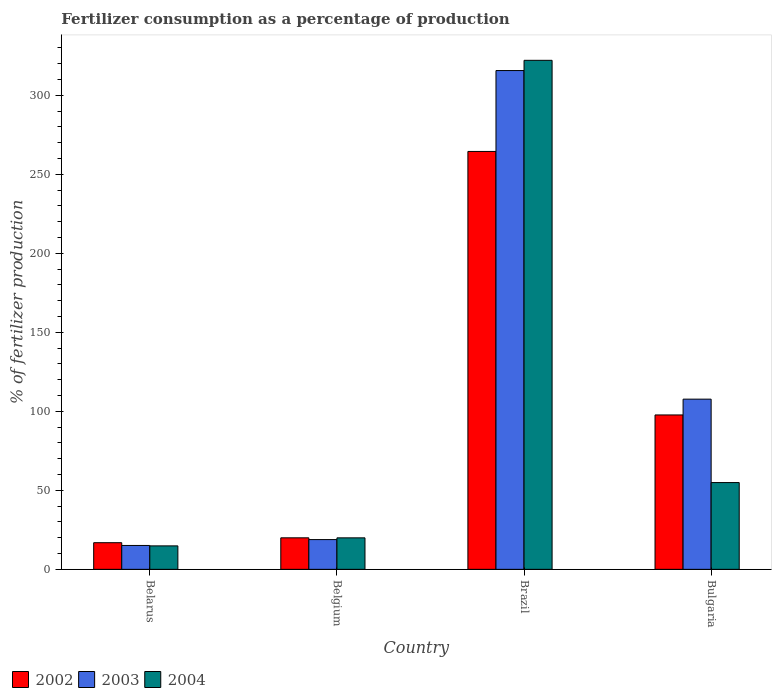How many different coloured bars are there?
Keep it short and to the point. 3. Are the number of bars per tick equal to the number of legend labels?
Give a very brief answer. Yes. Are the number of bars on each tick of the X-axis equal?
Provide a short and direct response. Yes. How many bars are there on the 1st tick from the left?
Your answer should be compact. 3. What is the percentage of fertilizers consumed in 2004 in Belgium?
Provide a succinct answer. 19.93. Across all countries, what is the maximum percentage of fertilizers consumed in 2002?
Give a very brief answer. 264.49. Across all countries, what is the minimum percentage of fertilizers consumed in 2003?
Your answer should be compact. 15.11. In which country was the percentage of fertilizers consumed in 2002 minimum?
Your response must be concise. Belarus. What is the total percentage of fertilizers consumed in 2004 in the graph?
Your response must be concise. 411.84. What is the difference between the percentage of fertilizers consumed in 2003 in Brazil and that in Bulgaria?
Keep it short and to the point. 207.97. What is the difference between the percentage of fertilizers consumed in 2002 in Belgium and the percentage of fertilizers consumed in 2003 in Belarus?
Provide a succinct answer. 4.83. What is the average percentage of fertilizers consumed in 2002 per country?
Make the answer very short. 99.75. What is the difference between the percentage of fertilizers consumed of/in 2004 and percentage of fertilizers consumed of/in 2002 in Belgium?
Your answer should be compact. -0.01. In how many countries, is the percentage of fertilizers consumed in 2002 greater than 310 %?
Offer a very short reply. 0. What is the ratio of the percentage of fertilizers consumed in 2003 in Belarus to that in Bulgaria?
Your response must be concise. 0.14. Is the difference between the percentage of fertilizers consumed in 2004 in Brazil and Bulgaria greater than the difference between the percentage of fertilizers consumed in 2002 in Brazil and Bulgaria?
Your response must be concise. Yes. What is the difference between the highest and the second highest percentage of fertilizers consumed in 2003?
Your answer should be very brief. 88.89. What is the difference between the highest and the lowest percentage of fertilizers consumed in 2004?
Make the answer very short. 307.32. In how many countries, is the percentage of fertilizers consumed in 2003 greater than the average percentage of fertilizers consumed in 2003 taken over all countries?
Give a very brief answer. 1. Is the sum of the percentage of fertilizers consumed in 2002 in Belgium and Bulgaria greater than the maximum percentage of fertilizers consumed in 2004 across all countries?
Your response must be concise. No. Is it the case that in every country, the sum of the percentage of fertilizers consumed in 2004 and percentage of fertilizers consumed in 2003 is greater than the percentage of fertilizers consumed in 2002?
Your answer should be compact. Yes. How many bars are there?
Offer a terse response. 12. Are all the bars in the graph horizontal?
Offer a very short reply. No. How many countries are there in the graph?
Provide a succinct answer. 4. What is the title of the graph?
Ensure brevity in your answer.  Fertilizer consumption as a percentage of production. Does "1988" appear as one of the legend labels in the graph?
Your answer should be compact. No. What is the label or title of the X-axis?
Your answer should be compact. Country. What is the label or title of the Y-axis?
Your answer should be very brief. % of fertilizer production. What is the % of fertilizer production of 2002 in Belarus?
Your answer should be compact. 16.86. What is the % of fertilizer production in 2003 in Belarus?
Offer a terse response. 15.11. What is the % of fertilizer production of 2004 in Belarus?
Your response must be concise. 14.84. What is the % of fertilizer production in 2002 in Belgium?
Your answer should be very brief. 19.94. What is the % of fertilizer production in 2003 in Belgium?
Your answer should be very brief. 18.83. What is the % of fertilizer production in 2004 in Belgium?
Offer a very short reply. 19.93. What is the % of fertilizer production in 2002 in Brazil?
Make the answer very short. 264.49. What is the % of fertilizer production in 2003 in Brazil?
Provide a succinct answer. 315.68. What is the % of fertilizer production of 2004 in Brazil?
Offer a very short reply. 322.16. What is the % of fertilizer production in 2002 in Bulgaria?
Your response must be concise. 97.71. What is the % of fertilizer production of 2003 in Bulgaria?
Provide a succinct answer. 107.72. What is the % of fertilizer production in 2004 in Bulgaria?
Provide a succinct answer. 54.91. Across all countries, what is the maximum % of fertilizer production in 2002?
Keep it short and to the point. 264.49. Across all countries, what is the maximum % of fertilizer production of 2003?
Give a very brief answer. 315.68. Across all countries, what is the maximum % of fertilizer production of 2004?
Keep it short and to the point. 322.16. Across all countries, what is the minimum % of fertilizer production in 2002?
Your answer should be very brief. 16.86. Across all countries, what is the minimum % of fertilizer production in 2003?
Your answer should be compact. 15.11. Across all countries, what is the minimum % of fertilizer production in 2004?
Your response must be concise. 14.84. What is the total % of fertilizer production of 2002 in the graph?
Your response must be concise. 399. What is the total % of fertilizer production in 2003 in the graph?
Offer a terse response. 457.34. What is the total % of fertilizer production in 2004 in the graph?
Your response must be concise. 411.84. What is the difference between the % of fertilizer production in 2002 in Belarus and that in Belgium?
Provide a succinct answer. -3.08. What is the difference between the % of fertilizer production in 2003 in Belarus and that in Belgium?
Give a very brief answer. -3.72. What is the difference between the % of fertilizer production of 2004 in Belarus and that in Belgium?
Offer a very short reply. -5.09. What is the difference between the % of fertilizer production in 2002 in Belarus and that in Brazil?
Offer a very short reply. -247.63. What is the difference between the % of fertilizer production of 2003 in Belarus and that in Brazil?
Provide a succinct answer. -300.57. What is the difference between the % of fertilizer production of 2004 in Belarus and that in Brazil?
Your response must be concise. -307.31. What is the difference between the % of fertilizer production in 2002 in Belarus and that in Bulgaria?
Ensure brevity in your answer.  -80.85. What is the difference between the % of fertilizer production in 2003 in Belarus and that in Bulgaria?
Your response must be concise. -92.61. What is the difference between the % of fertilizer production in 2004 in Belarus and that in Bulgaria?
Your response must be concise. -40.07. What is the difference between the % of fertilizer production of 2002 in Belgium and that in Brazil?
Your answer should be very brief. -244.55. What is the difference between the % of fertilizer production in 2003 in Belgium and that in Brazil?
Your response must be concise. -296.85. What is the difference between the % of fertilizer production in 2004 in Belgium and that in Brazil?
Your answer should be compact. -302.23. What is the difference between the % of fertilizer production in 2002 in Belgium and that in Bulgaria?
Give a very brief answer. -77.77. What is the difference between the % of fertilizer production of 2003 in Belgium and that in Bulgaria?
Keep it short and to the point. -88.89. What is the difference between the % of fertilizer production of 2004 in Belgium and that in Bulgaria?
Offer a very short reply. -34.98. What is the difference between the % of fertilizer production of 2002 in Brazil and that in Bulgaria?
Keep it short and to the point. 166.78. What is the difference between the % of fertilizer production in 2003 in Brazil and that in Bulgaria?
Offer a very short reply. 207.97. What is the difference between the % of fertilizer production in 2004 in Brazil and that in Bulgaria?
Offer a terse response. 267.25. What is the difference between the % of fertilizer production in 2002 in Belarus and the % of fertilizer production in 2003 in Belgium?
Your answer should be compact. -1.97. What is the difference between the % of fertilizer production in 2002 in Belarus and the % of fertilizer production in 2004 in Belgium?
Offer a very short reply. -3.07. What is the difference between the % of fertilizer production of 2003 in Belarus and the % of fertilizer production of 2004 in Belgium?
Your answer should be very brief. -4.82. What is the difference between the % of fertilizer production of 2002 in Belarus and the % of fertilizer production of 2003 in Brazil?
Provide a succinct answer. -298.83. What is the difference between the % of fertilizer production in 2002 in Belarus and the % of fertilizer production in 2004 in Brazil?
Your answer should be compact. -305.3. What is the difference between the % of fertilizer production of 2003 in Belarus and the % of fertilizer production of 2004 in Brazil?
Give a very brief answer. -307.05. What is the difference between the % of fertilizer production in 2002 in Belarus and the % of fertilizer production in 2003 in Bulgaria?
Offer a very short reply. -90.86. What is the difference between the % of fertilizer production of 2002 in Belarus and the % of fertilizer production of 2004 in Bulgaria?
Keep it short and to the point. -38.05. What is the difference between the % of fertilizer production of 2003 in Belarus and the % of fertilizer production of 2004 in Bulgaria?
Offer a very short reply. -39.8. What is the difference between the % of fertilizer production of 2002 in Belgium and the % of fertilizer production of 2003 in Brazil?
Ensure brevity in your answer.  -295.74. What is the difference between the % of fertilizer production of 2002 in Belgium and the % of fertilizer production of 2004 in Brazil?
Your answer should be compact. -302.22. What is the difference between the % of fertilizer production in 2003 in Belgium and the % of fertilizer production in 2004 in Brazil?
Your response must be concise. -303.33. What is the difference between the % of fertilizer production of 2002 in Belgium and the % of fertilizer production of 2003 in Bulgaria?
Make the answer very short. -87.78. What is the difference between the % of fertilizer production of 2002 in Belgium and the % of fertilizer production of 2004 in Bulgaria?
Your answer should be very brief. -34.97. What is the difference between the % of fertilizer production in 2003 in Belgium and the % of fertilizer production in 2004 in Bulgaria?
Ensure brevity in your answer.  -36.08. What is the difference between the % of fertilizer production in 2002 in Brazil and the % of fertilizer production in 2003 in Bulgaria?
Your response must be concise. 156.77. What is the difference between the % of fertilizer production in 2002 in Brazil and the % of fertilizer production in 2004 in Bulgaria?
Your answer should be very brief. 209.58. What is the difference between the % of fertilizer production of 2003 in Brazil and the % of fertilizer production of 2004 in Bulgaria?
Offer a terse response. 260.77. What is the average % of fertilizer production in 2002 per country?
Offer a terse response. 99.75. What is the average % of fertilizer production in 2003 per country?
Give a very brief answer. 114.34. What is the average % of fertilizer production in 2004 per country?
Provide a short and direct response. 102.96. What is the difference between the % of fertilizer production in 2002 and % of fertilizer production in 2003 in Belarus?
Your answer should be very brief. 1.75. What is the difference between the % of fertilizer production of 2002 and % of fertilizer production of 2004 in Belarus?
Provide a succinct answer. 2.01. What is the difference between the % of fertilizer production of 2003 and % of fertilizer production of 2004 in Belarus?
Your answer should be compact. 0.27. What is the difference between the % of fertilizer production of 2002 and % of fertilizer production of 2003 in Belgium?
Keep it short and to the point. 1.11. What is the difference between the % of fertilizer production in 2002 and % of fertilizer production in 2004 in Belgium?
Make the answer very short. 0.01. What is the difference between the % of fertilizer production in 2003 and % of fertilizer production in 2004 in Belgium?
Offer a terse response. -1.1. What is the difference between the % of fertilizer production in 2002 and % of fertilizer production in 2003 in Brazil?
Your response must be concise. -51.19. What is the difference between the % of fertilizer production of 2002 and % of fertilizer production of 2004 in Brazil?
Your response must be concise. -57.67. What is the difference between the % of fertilizer production of 2003 and % of fertilizer production of 2004 in Brazil?
Your answer should be very brief. -6.47. What is the difference between the % of fertilizer production of 2002 and % of fertilizer production of 2003 in Bulgaria?
Keep it short and to the point. -10.01. What is the difference between the % of fertilizer production of 2002 and % of fertilizer production of 2004 in Bulgaria?
Keep it short and to the point. 42.8. What is the difference between the % of fertilizer production of 2003 and % of fertilizer production of 2004 in Bulgaria?
Your answer should be compact. 52.8. What is the ratio of the % of fertilizer production in 2002 in Belarus to that in Belgium?
Your answer should be very brief. 0.85. What is the ratio of the % of fertilizer production of 2003 in Belarus to that in Belgium?
Your answer should be compact. 0.8. What is the ratio of the % of fertilizer production of 2004 in Belarus to that in Belgium?
Ensure brevity in your answer.  0.74. What is the ratio of the % of fertilizer production in 2002 in Belarus to that in Brazil?
Your response must be concise. 0.06. What is the ratio of the % of fertilizer production of 2003 in Belarus to that in Brazil?
Make the answer very short. 0.05. What is the ratio of the % of fertilizer production of 2004 in Belarus to that in Brazil?
Ensure brevity in your answer.  0.05. What is the ratio of the % of fertilizer production in 2002 in Belarus to that in Bulgaria?
Offer a terse response. 0.17. What is the ratio of the % of fertilizer production of 2003 in Belarus to that in Bulgaria?
Your response must be concise. 0.14. What is the ratio of the % of fertilizer production of 2004 in Belarus to that in Bulgaria?
Keep it short and to the point. 0.27. What is the ratio of the % of fertilizer production in 2002 in Belgium to that in Brazil?
Your answer should be very brief. 0.08. What is the ratio of the % of fertilizer production of 2003 in Belgium to that in Brazil?
Your answer should be very brief. 0.06. What is the ratio of the % of fertilizer production in 2004 in Belgium to that in Brazil?
Ensure brevity in your answer.  0.06. What is the ratio of the % of fertilizer production of 2002 in Belgium to that in Bulgaria?
Your answer should be very brief. 0.2. What is the ratio of the % of fertilizer production in 2003 in Belgium to that in Bulgaria?
Keep it short and to the point. 0.17. What is the ratio of the % of fertilizer production of 2004 in Belgium to that in Bulgaria?
Your answer should be compact. 0.36. What is the ratio of the % of fertilizer production of 2002 in Brazil to that in Bulgaria?
Offer a terse response. 2.71. What is the ratio of the % of fertilizer production in 2003 in Brazil to that in Bulgaria?
Provide a succinct answer. 2.93. What is the ratio of the % of fertilizer production of 2004 in Brazil to that in Bulgaria?
Offer a terse response. 5.87. What is the difference between the highest and the second highest % of fertilizer production in 2002?
Your answer should be compact. 166.78. What is the difference between the highest and the second highest % of fertilizer production of 2003?
Ensure brevity in your answer.  207.97. What is the difference between the highest and the second highest % of fertilizer production of 2004?
Provide a succinct answer. 267.25. What is the difference between the highest and the lowest % of fertilizer production in 2002?
Your response must be concise. 247.63. What is the difference between the highest and the lowest % of fertilizer production in 2003?
Offer a terse response. 300.57. What is the difference between the highest and the lowest % of fertilizer production in 2004?
Provide a succinct answer. 307.31. 